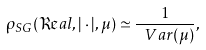<formula> <loc_0><loc_0><loc_500><loc_500>\rho _ { S G } ( \Re a l , | \cdot | , \mu ) \simeq \frac { 1 } { \ V a r ( \mu ) } ,</formula> 